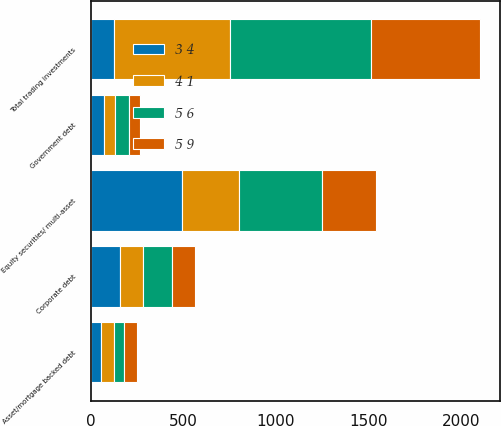Convert chart. <chart><loc_0><loc_0><loc_500><loc_500><stacked_bar_chart><ecel><fcel>Equity securities/ multi-asset<fcel>Corporate debt<fcel>Government debt<fcel>Asset/mortgage backed debt<fcel>Total trading investments<nl><fcel>5 6<fcel>446<fcel>152<fcel>72<fcel>56<fcel>760<nl><fcel>3 4<fcel>493<fcel>157<fcel>73<fcel>56<fcel>128<nl><fcel>5 9<fcel>290<fcel>128<fcel>60<fcel>70<fcel>589<nl><fcel>4 1<fcel>308<fcel>128<fcel>60<fcel>70<fcel>625<nl></chart> 